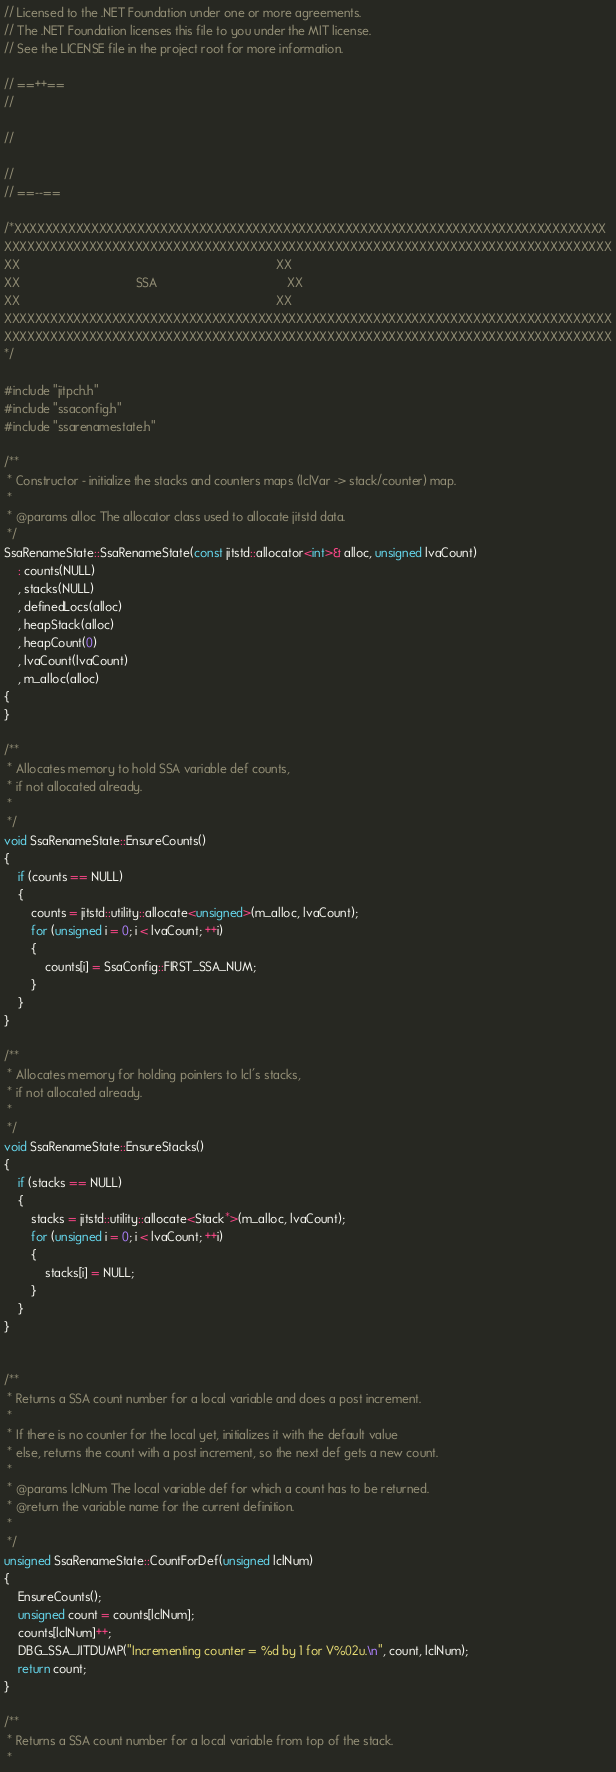<code> <loc_0><loc_0><loc_500><loc_500><_C++_>// Licensed to the .NET Foundation under one or more agreements.
// The .NET Foundation licenses this file to you under the MIT license.
// See the LICENSE file in the project root for more information.

// ==++==
//

//

//
// ==--==

/*XXXXXXXXXXXXXXXXXXXXXXXXXXXXXXXXXXXXXXXXXXXXXXXXXXXXXXXXXXXXXXXXXXXXXXXXXXXXX
XXXXXXXXXXXXXXXXXXXXXXXXXXXXXXXXXXXXXXXXXXXXXXXXXXXXXXXXXXXXXXXXXXXXXXXXXXXXXXX
XX                                                                           XX
XX                                  SSA                                      XX
XX                                                                           XX
XXXXXXXXXXXXXXXXXXXXXXXXXXXXXXXXXXXXXXXXXXXXXXXXXXXXXXXXXXXXXXXXXXXXXXXXXXXXXXX
XXXXXXXXXXXXXXXXXXXXXXXXXXXXXXXXXXXXXXXXXXXXXXXXXXXXXXXXXXXXXXXXXXXXXXXXXXXXXXX
*/

#include "jitpch.h"
#include "ssaconfig.h"
#include "ssarenamestate.h"

/**
 * Constructor - initialize the stacks and counters maps (lclVar -> stack/counter) map.
 *
 * @params alloc The allocator class used to allocate jitstd data.
 */
SsaRenameState::SsaRenameState(const jitstd::allocator<int>& alloc, unsigned lvaCount)
    : counts(NULL)
    , stacks(NULL)
    , definedLocs(alloc)
    , heapStack(alloc)
    , heapCount(0)
    , lvaCount(lvaCount)
    , m_alloc(alloc)
{
}

/**
 * Allocates memory to hold SSA variable def counts,
 * if not allocated already.
 *
 */
void SsaRenameState::EnsureCounts()
{
    if (counts == NULL)
    {
        counts = jitstd::utility::allocate<unsigned>(m_alloc, lvaCount);
        for (unsigned i = 0; i < lvaCount; ++i)
        {
            counts[i] = SsaConfig::FIRST_SSA_NUM;
        }
    }
}

/**
 * Allocates memory for holding pointers to lcl's stacks,
 * if not allocated already.
 *
 */
void SsaRenameState::EnsureStacks()
{
    if (stacks == NULL)
    {
        stacks = jitstd::utility::allocate<Stack*>(m_alloc, lvaCount);
        for (unsigned i = 0; i < lvaCount; ++i)
        {
            stacks[i] = NULL;
        }
    }
}


/**
 * Returns a SSA count number for a local variable and does a post increment.
 *
 * If there is no counter for the local yet, initializes it with the default value
 * else, returns the count with a post increment, so the next def gets a new count.
 *
 * @params lclNum The local variable def for which a count has to be returned.
 * @return the variable name for the current definition.
 *
 */
unsigned SsaRenameState::CountForDef(unsigned lclNum)
{
    EnsureCounts();
    unsigned count = counts[lclNum];
    counts[lclNum]++;
    DBG_SSA_JITDUMP("Incrementing counter = %d by 1 for V%02u.\n", count, lclNum);
    return count;
}

/**
 * Returns a SSA count number for a local variable from top of the stack.
 *</code> 